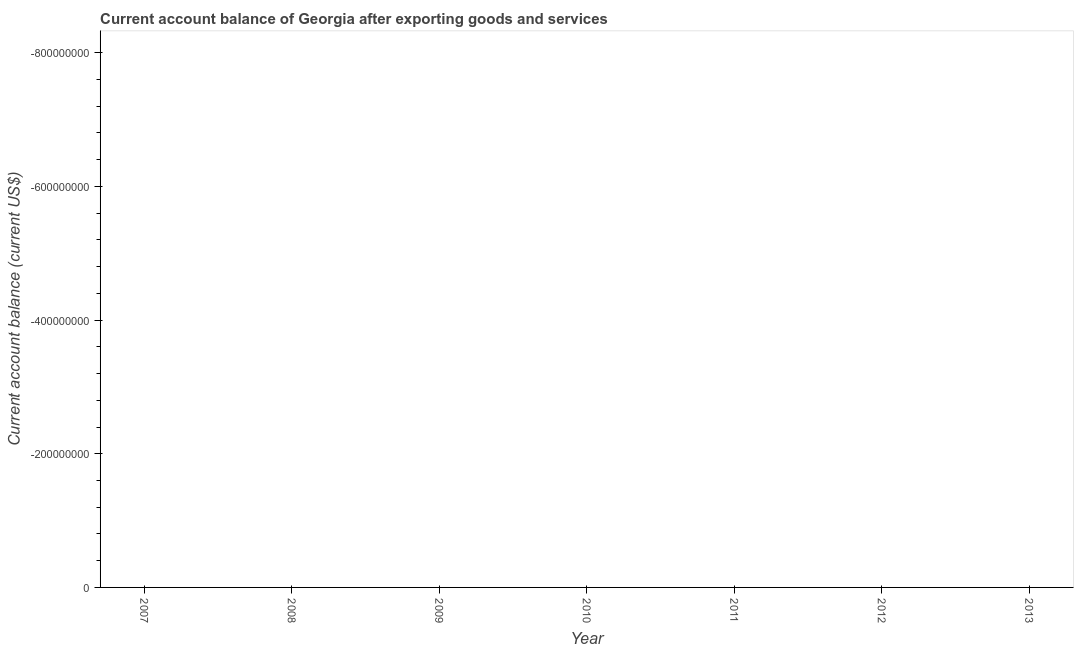How many dotlines are there?
Make the answer very short. 0. Are the values on the major ticks of Y-axis written in scientific E-notation?
Your answer should be compact. No. Does the graph contain any zero values?
Give a very brief answer. Yes. What is the title of the graph?
Keep it short and to the point. Current account balance of Georgia after exporting goods and services. What is the label or title of the X-axis?
Your response must be concise. Year. What is the label or title of the Y-axis?
Your response must be concise. Current account balance (current US$). What is the Current account balance (current US$) in 2009?
Your answer should be compact. 0. 